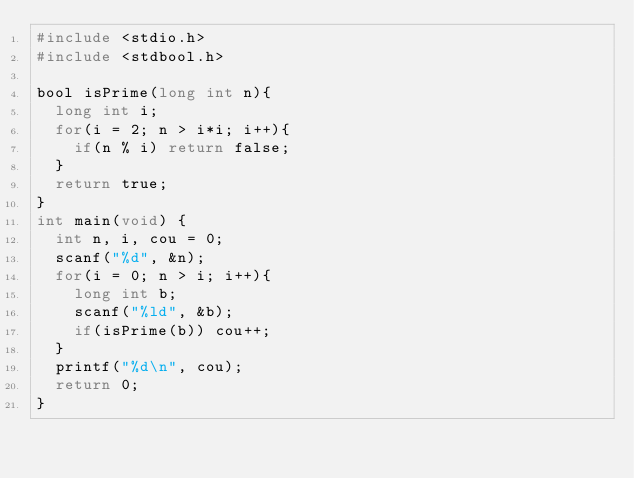<code> <loc_0><loc_0><loc_500><loc_500><_C_>#include <stdio.h>
#include <stdbool.h>

bool isPrime(long int n){
	long int i;
	for(i = 2; n > i*i; i++){
		if(n % i) return false;
	}
	return true;
}
int main(void) {
	int n, i, cou = 0;
	scanf("%d", &n);
	for(i = 0; n > i; i++){
		long int b;
		scanf("%ld", &b);
		if(isPrime(b)) cou++;
	}
	printf("%d\n", cou);
	return 0;
}</code> 